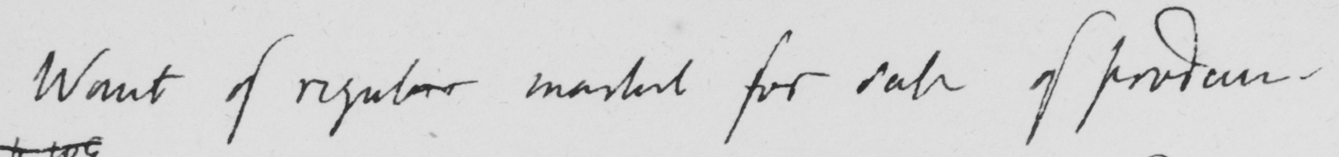Please provide the text content of this handwritten line. Want of regular market for sale of produce 